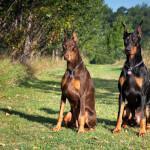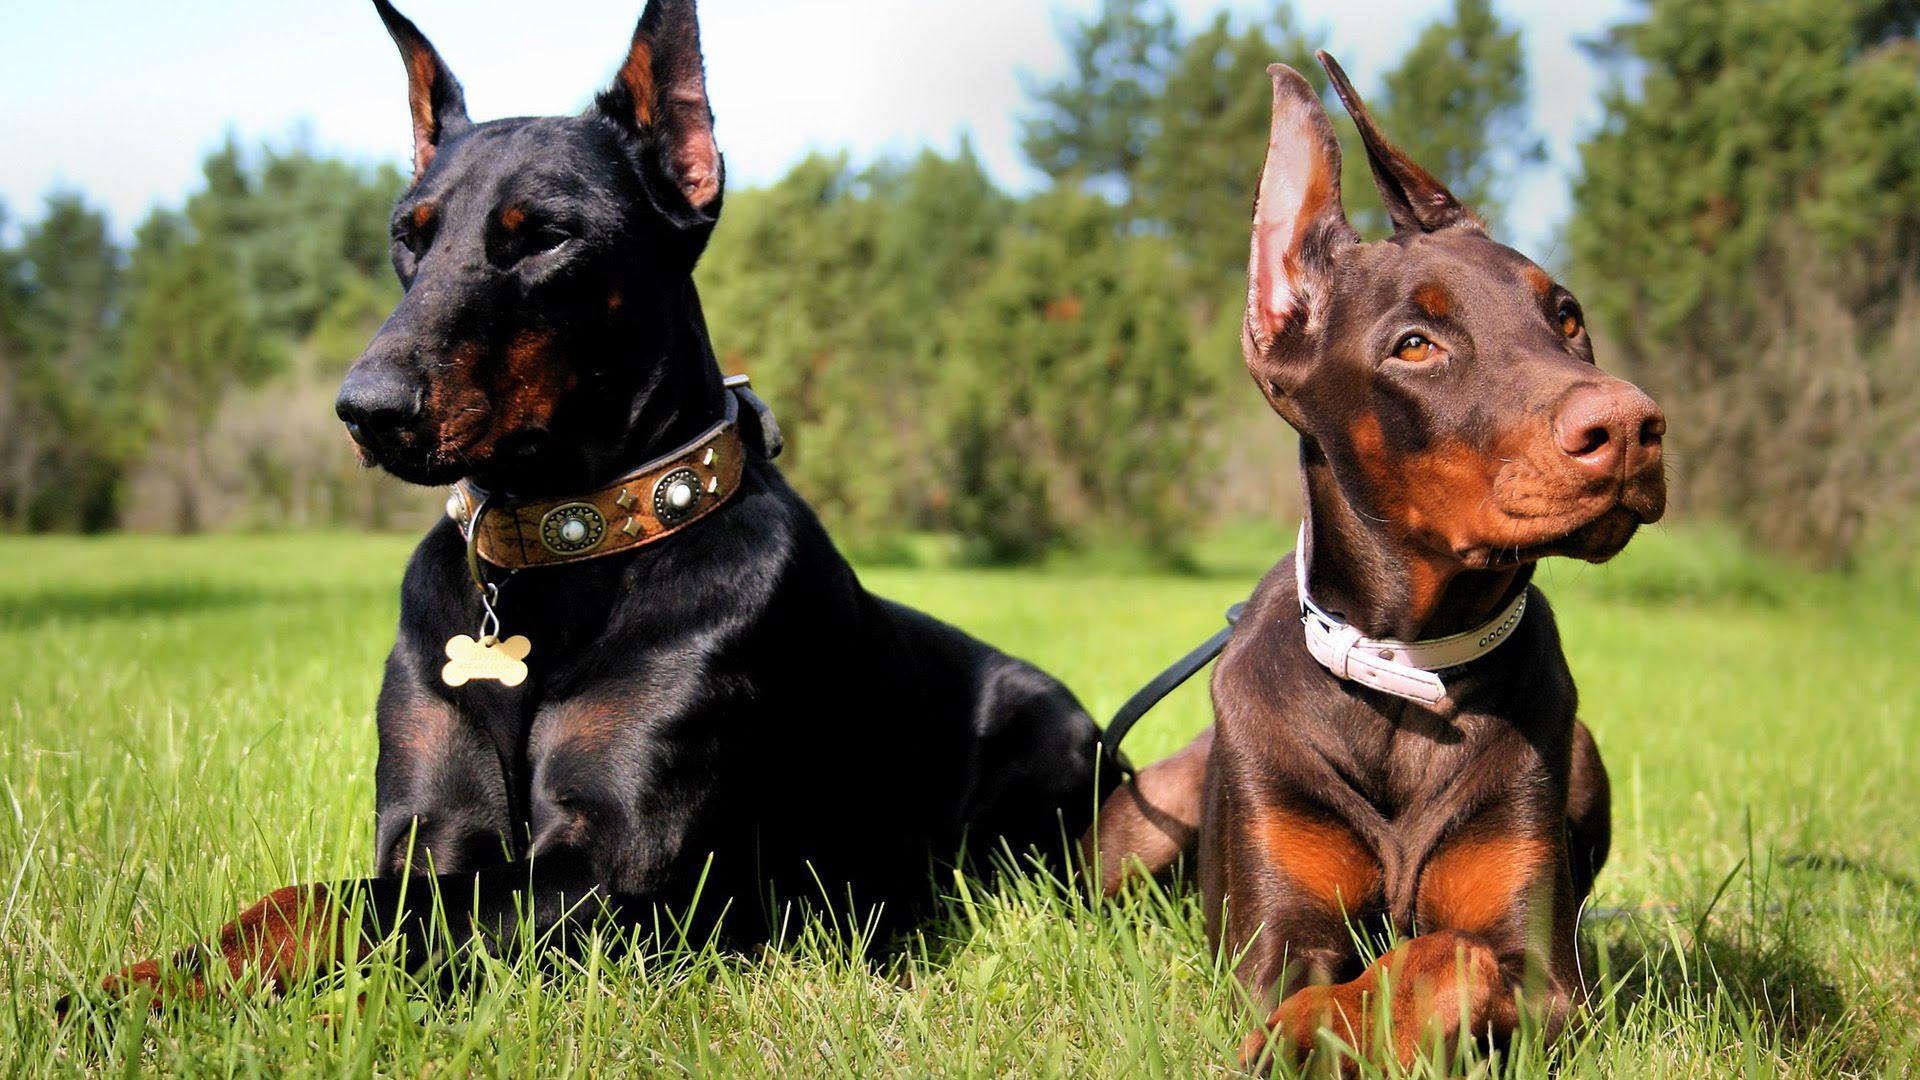The first image is the image on the left, the second image is the image on the right. Given the left and right images, does the statement "Two dogs are sitting in the grass in the image on the left, while two lie in the grass in the image on the right." hold true? Answer yes or no. Yes. The first image is the image on the left, the second image is the image on the right. For the images shown, is this caption "Every image shows exactly two dogs wearing collars, and no dog is actively hooked up to a leash." true? Answer yes or no. Yes. 